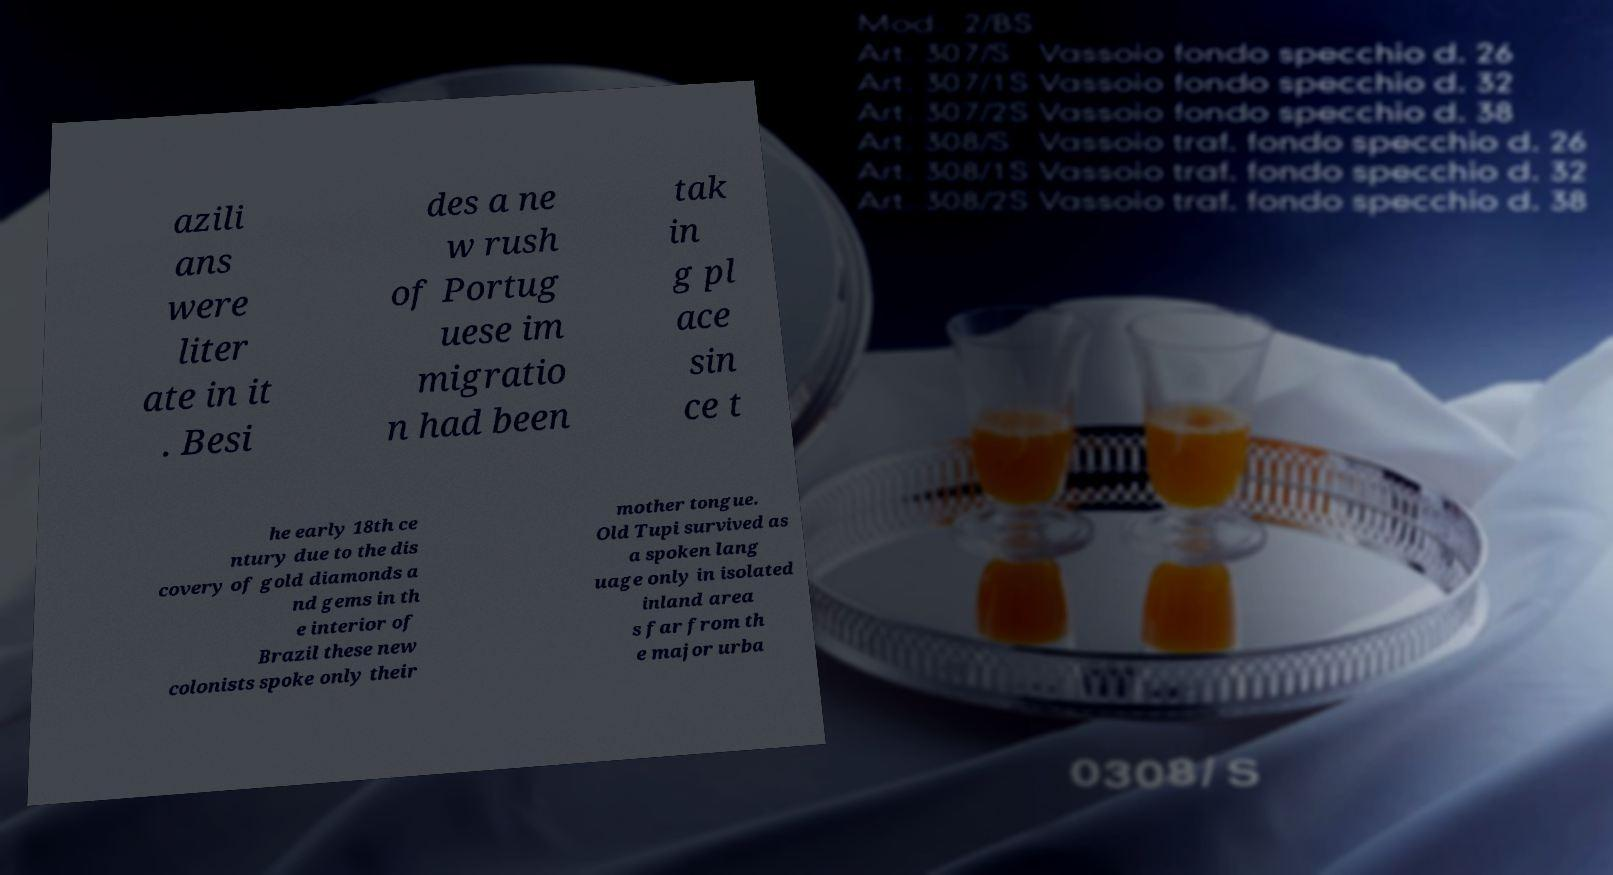I need the written content from this picture converted into text. Can you do that? azili ans were liter ate in it . Besi des a ne w rush of Portug uese im migratio n had been tak in g pl ace sin ce t he early 18th ce ntury due to the dis covery of gold diamonds a nd gems in th e interior of Brazil these new colonists spoke only their mother tongue. Old Tupi survived as a spoken lang uage only in isolated inland area s far from th e major urba 